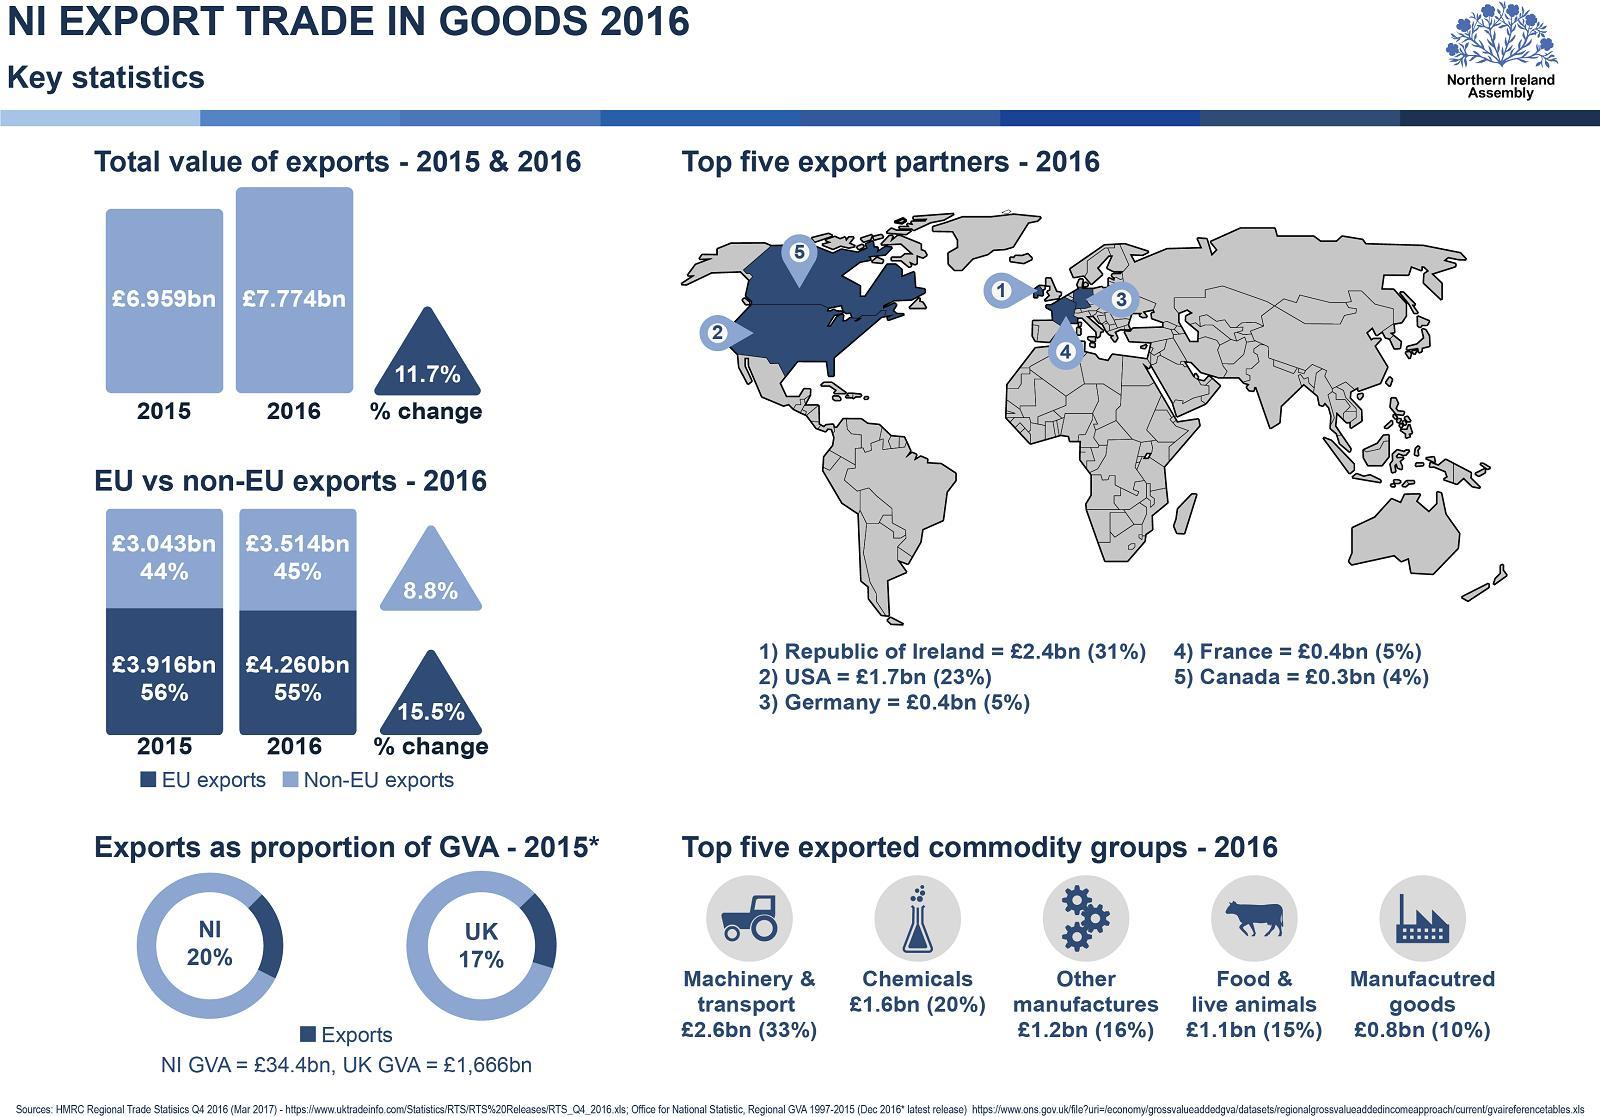Which exports was higher in 2015 - EU or non-EU?
Answer the question with a short phrase. EU How many export partners marked in the map are in Europe? 3 What was percentage of manufactured goods export? 10 What is the second most exported commodity group of 2016? Chemicals 